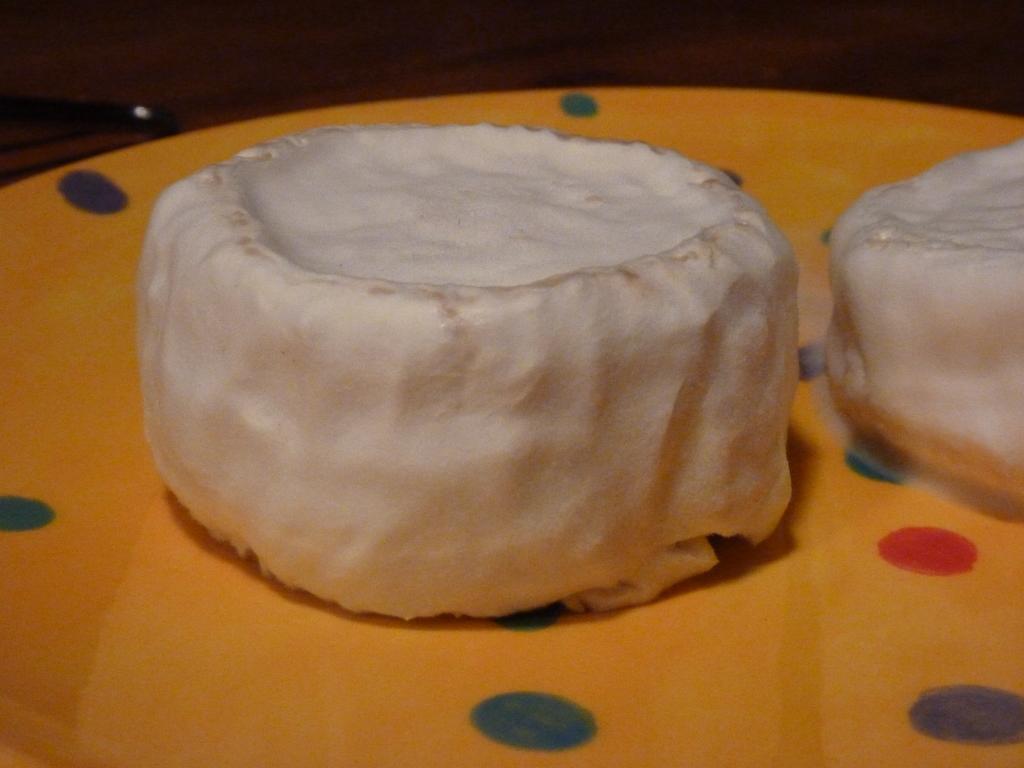Please provide a concise description of this image. In this image there is some food item on a plate. 